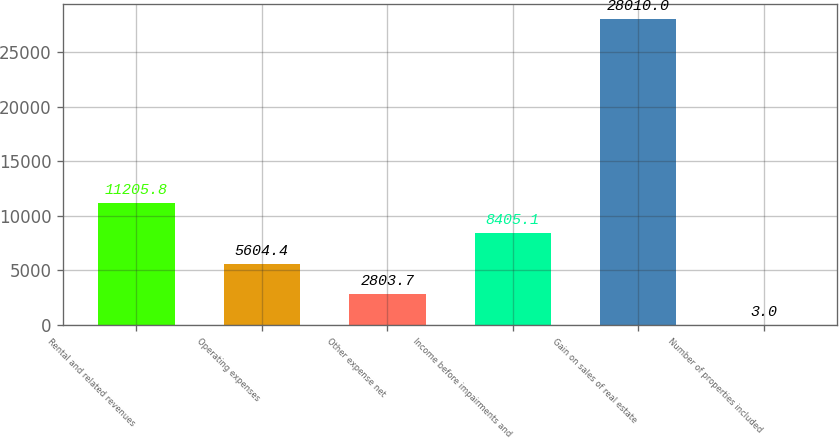<chart> <loc_0><loc_0><loc_500><loc_500><bar_chart><fcel>Rental and related revenues<fcel>Operating expenses<fcel>Other expense net<fcel>Income before impairments and<fcel>Gain on sales of real estate<fcel>Number of properties included<nl><fcel>11205.8<fcel>5604.4<fcel>2803.7<fcel>8405.1<fcel>28010<fcel>3<nl></chart> 